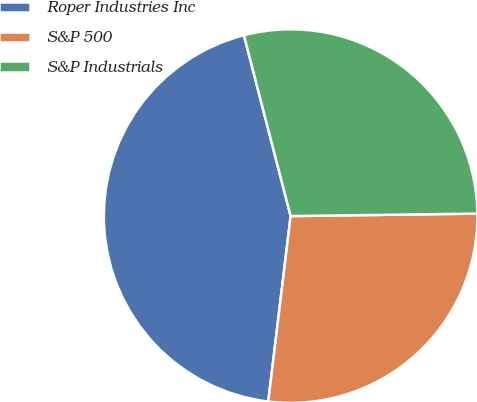Convert chart. <chart><loc_0><loc_0><loc_500><loc_500><pie_chart><fcel>Roper Industries Inc<fcel>S&P 500<fcel>S&P Industrials<nl><fcel>44.06%<fcel>27.12%<fcel>28.81%<nl></chart> 